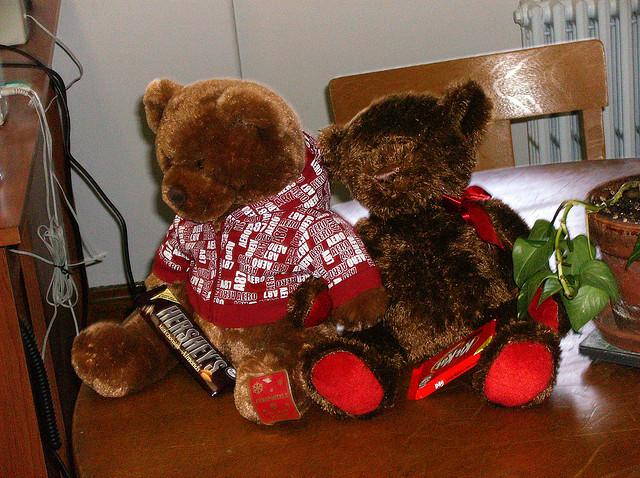What kind of candy bar is hanging on the leg of the teddy with a hoodie sweater put on? Please explain your reasoning. hersheys. The candy is hershey's. 